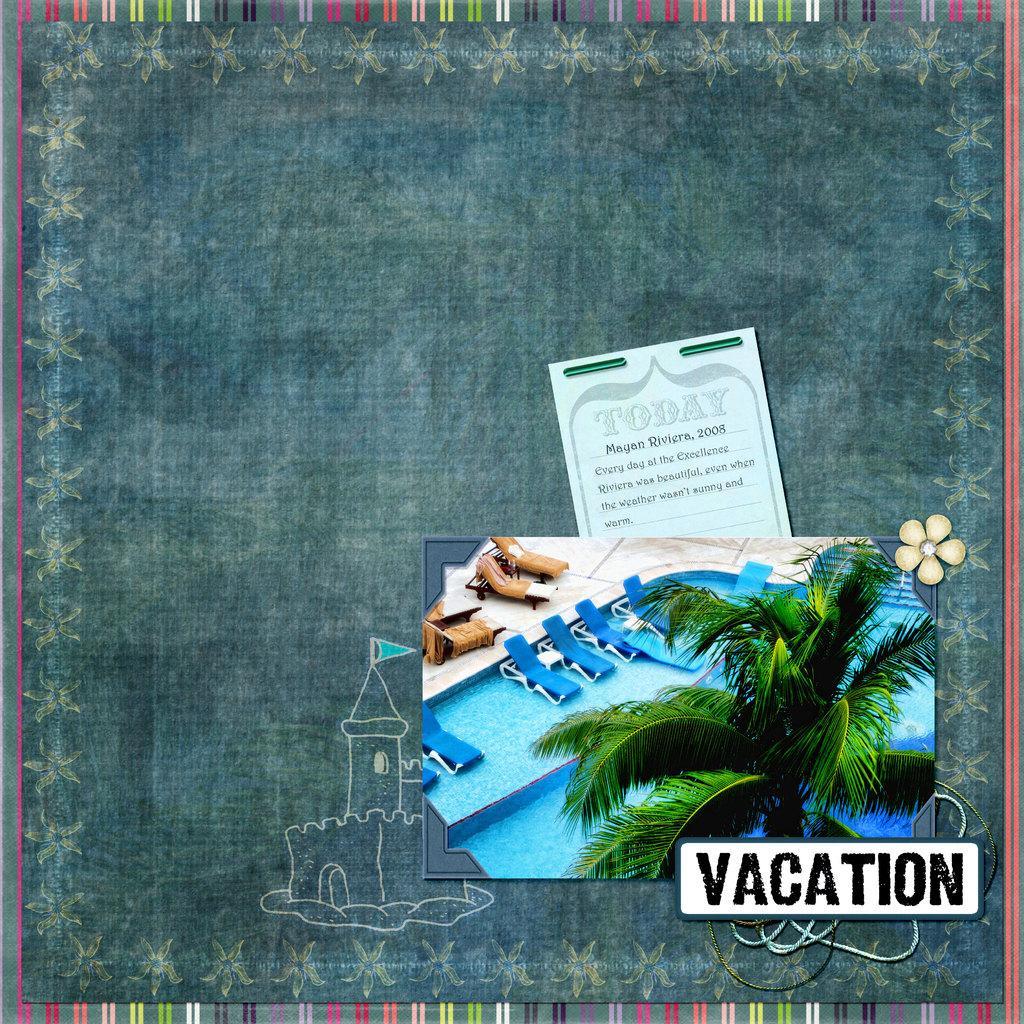Please provide a concise description of this image. In this image, we can see a board, there is a card and a photo, we can see the watermark and there is a painting. 